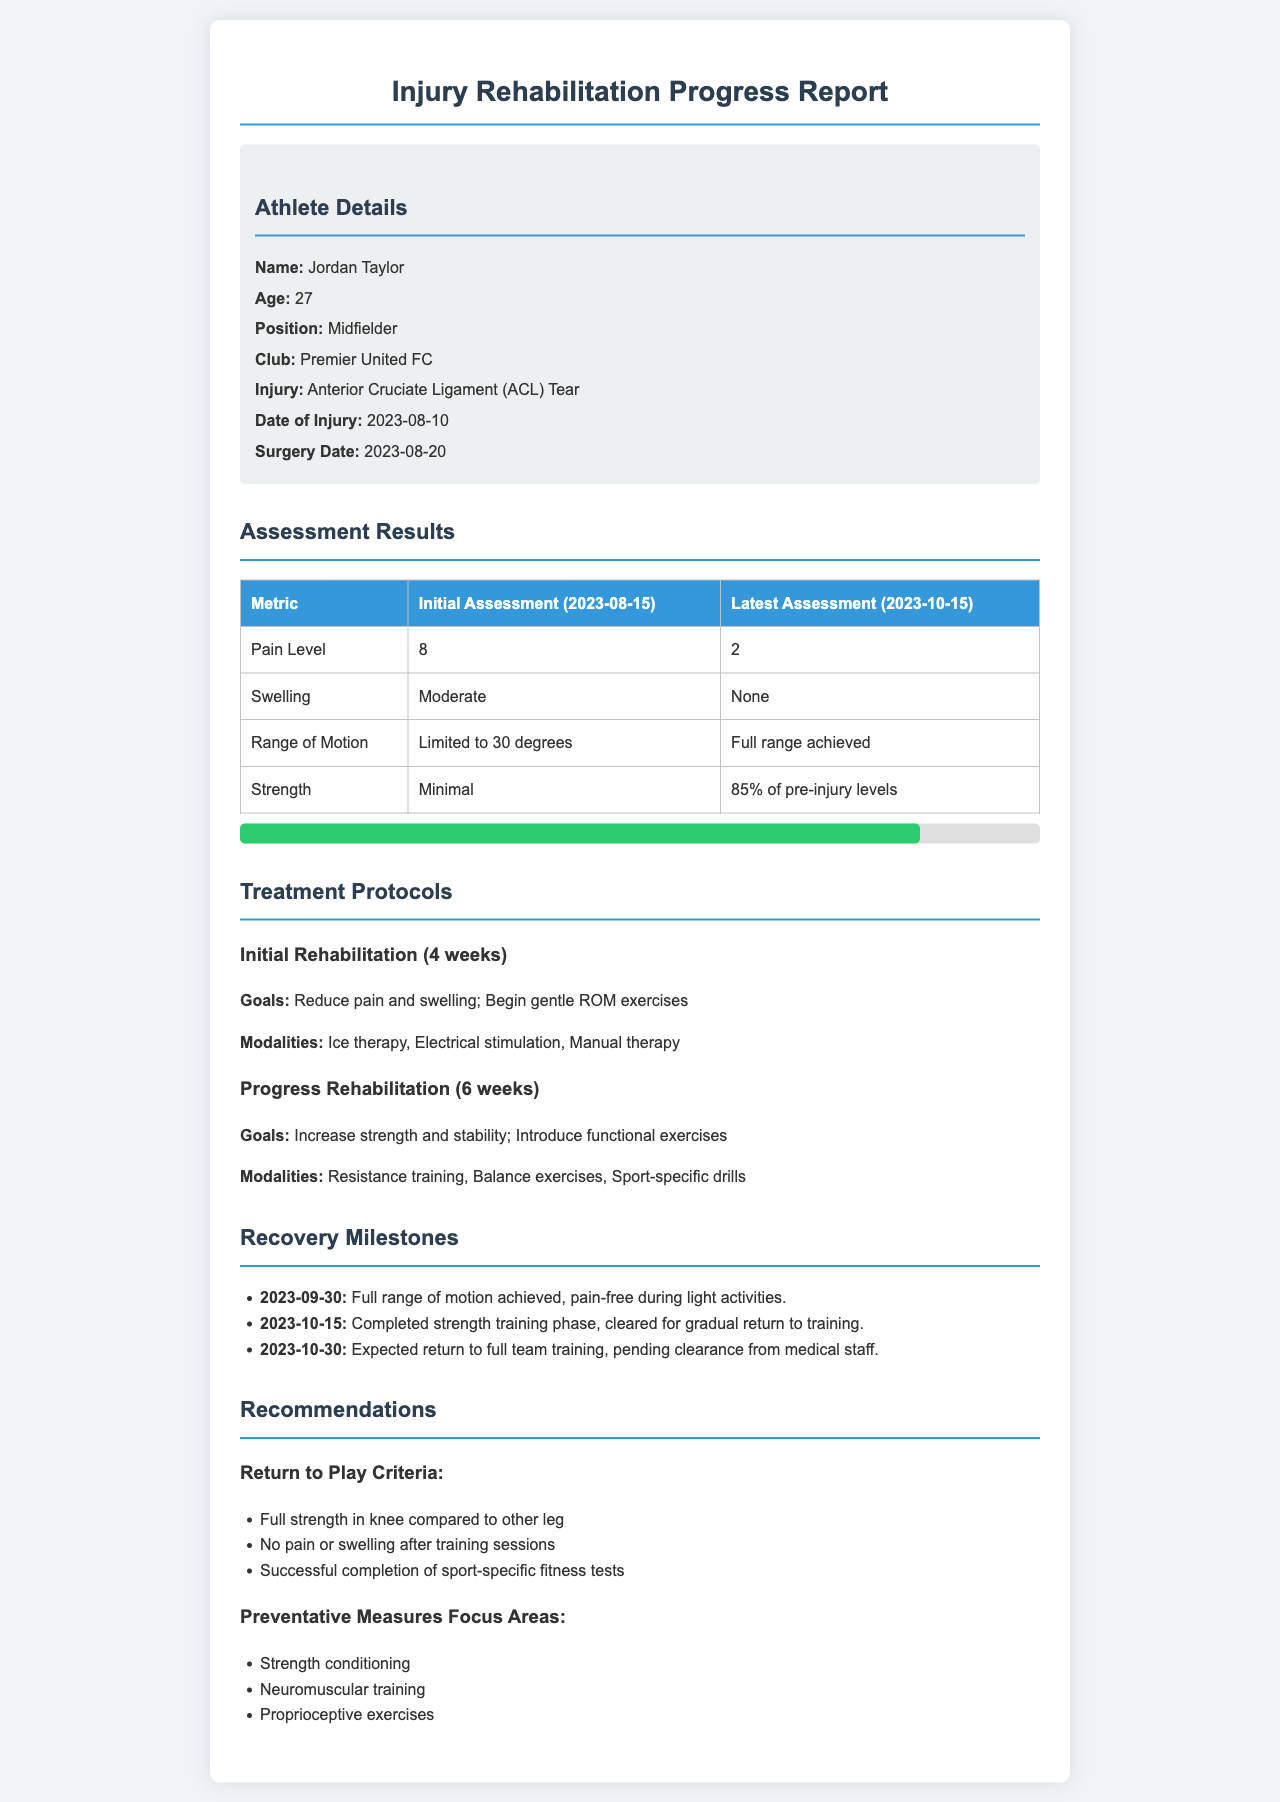What is the name of the athlete? The athlete's name is mentioned in the information section of the document as Jordan Taylor.
Answer: Jordan Taylor What is the age of Jordan Taylor? The athlete's age is specifically stated as 27 years old in the document.
Answer: 27 What injury did Jordan Taylor sustain? The type of injury Jordan Taylor suffered is detailed in the document as an Anterior Cruciate Ligament (ACL) Tear.
Answer: Anterior Cruciate Ligament (ACL) Tear On what date did Jordan Taylor undergo surgery? The surgery date is provided in the document, which states it occurred on 2023-08-20.
Answer: 2023-08-20 What was the initial pain level assessed on 2023-08-15? The initial assessment clearly indicates a pain level of 8 on the metric table.
Answer: 8 By how much has Jordan Taylor's strength improved from initial assessment? Comparing the assessments, strength improved from minimal to 85% of pre-injury levels, highlighting significant recovery.
Answer: 85% What specific treatments were introduced in the Progress Rehabilitation phase? The document lists resistance training, balance exercises, and sport-specific drills as treatment modalities in the Progress Rehabilitation phase.
Answer: Resistance training, Balance exercises, Sport-specific drills What is one recommendation for return to play? The document outlines multiple criteria; one of them is achieving full strength in the knee compared to the other leg.
Answer: Full strength in knee compared to other leg When is the expected return to full team training? The document states that the expected return is on 2023-10-30, pending medical staff clearance.
Answer: 2023-10-30 